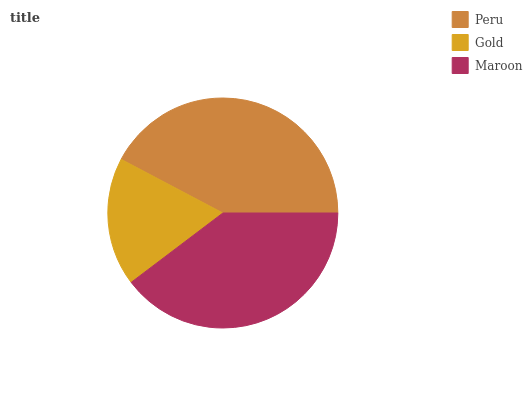Is Gold the minimum?
Answer yes or no. Yes. Is Peru the maximum?
Answer yes or no. Yes. Is Maroon the minimum?
Answer yes or no. No. Is Maroon the maximum?
Answer yes or no. No. Is Maroon greater than Gold?
Answer yes or no. Yes. Is Gold less than Maroon?
Answer yes or no. Yes. Is Gold greater than Maroon?
Answer yes or no. No. Is Maroon less than Gold?
Answer yes or no. No. Is Maroon the high median?
Answer yes or no. Yes. Is Maroon the low median?
Answer yes or no. Yes. Is Gold the high median?
Answer yes or no. No. Is Peru the low median?
Answer yes or no. No. 